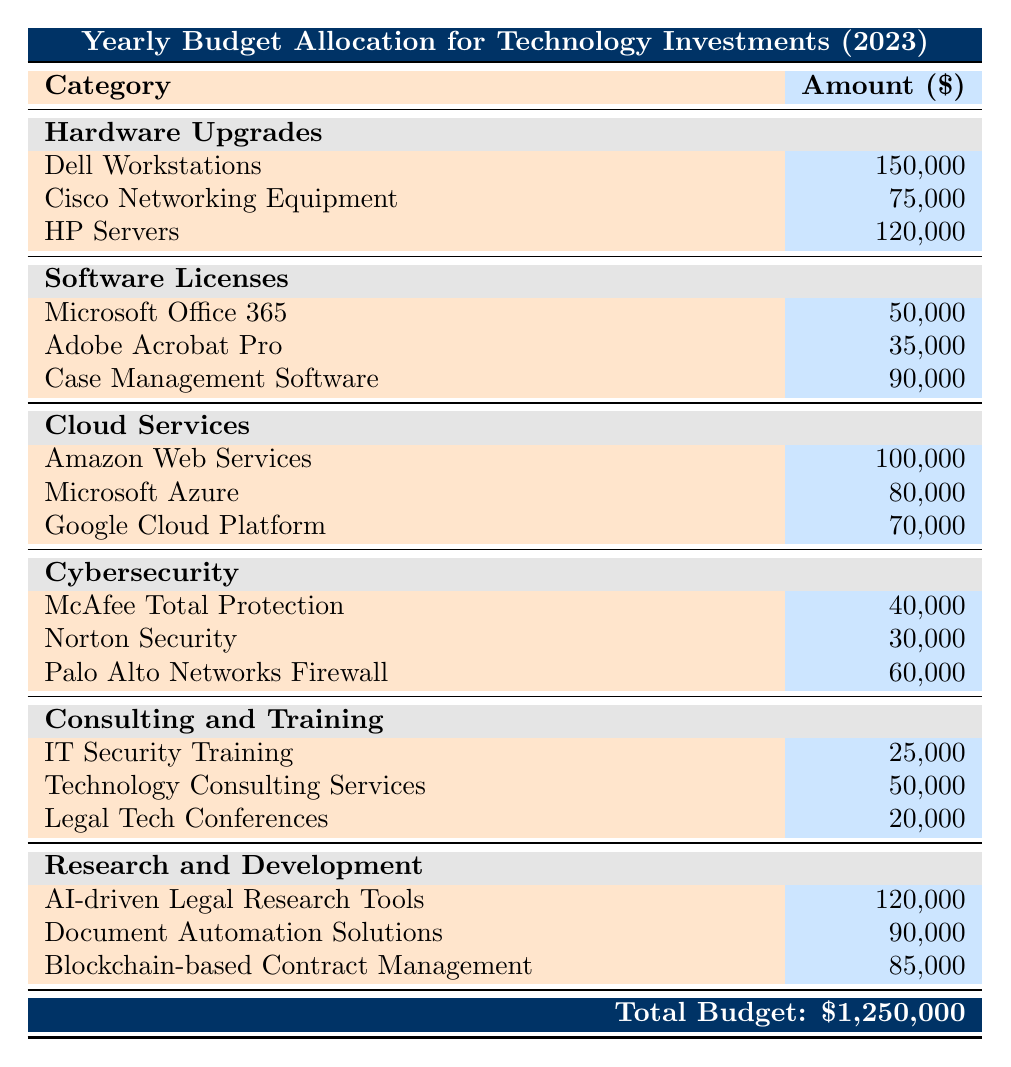What is the total budget allocated for technology investments in 2023? According to the table, the total budget allocated for technology investments in 2023 is explicitly stated at the bottom of the table as 1,250,000.
Answer: 1,250,000 Which hardware entity has the highest budget allocation? Looking at the "Hardware Upgrades" category, the amounts for the entities are Dell Workstations (150,000), Cisco Networking Equipment (75,000), and HP Servers (120,000). Dell Workstations has the highest amount at 150,000.
Answer: Dell Workstations How much is allocated for Software Licenses in total? The Software Licenses category includes Microsoft Office 365 (50,000), Adobe Acrobat Pro (35,000), and Case Management Software (90,000). Adding these amounts gives a total of 50,000 + 35,000 + 90,000 = 175,000.
Answer: 175,000 Is the budget allocation for Cybersecurity larger than that for Consulting and Training? The Cybersecurity budget includes McAfee Total Protection (40,000), Norton Security (30,000), and Palo Alto Networks Firewall (60,000), totaling 40,000 + 30,000 + 60,000 = 130,000. The Consulting and Training budget includes IT Security Training (25,000), Technology Consulting Services (50,000), and Legal Tech Conferences (20,000), totaling 25,000 + 50,000 + 20,000 = 95,000. Since 130,000 is greater than 95,000, the statement is true.
Answer: Yes What is the average budget allocation for the entities under Research and Development? The Research and Development budget consists of three entities: AI-driven Legal Research Tools (120,000), Document Automation Solutions (90,000), and Blockchain-based Contract Management (85,000). To find the average, sum these amounts: 120,000 + 90,000 + 85,000 = 295,000, then divide by 3 (295,000 / 3) which equals approximately 98,333.33. Rounding gives an average of 98,333.33.
Answer: 98,333.33 